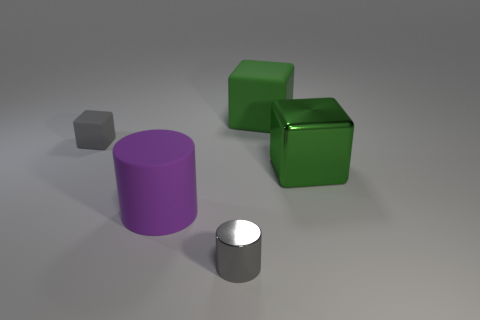What shape is the matte object that is right of the small gray rubber object and to the left of the green rubber thing?
Your answer should be very brief. Cylinder. Is there a tiny block of the same color as the tiny shiny cylinder?
Offer a very short reply. Yes. Are any tiny gray metallic objects visible?
Make the answer very short. Yes. There is a rubber cube to the left of the large matte cube; what is its color?
Make the answer very short. Gray. Does the shiny cube have the same size as the metal thing left of the big metal thing?
Provide a succinct answer. No. What is the size of the matte thing that is behind the big cylinder and on the right side of the gray matte object?
Your answer should be compact. Large. Is there a small cylinder made of the same material as the big purple object?
Keep it short and to the point. No. What is the shape of the green matte object?
Ensure brevity in your answer.  Cube. Do the green metallic object and the purple matte cylinder have the same size?
Give a very brief answer. Yes. How many other things are there of the same shape as the large shiny thing?
Offer a terse response. 2. 